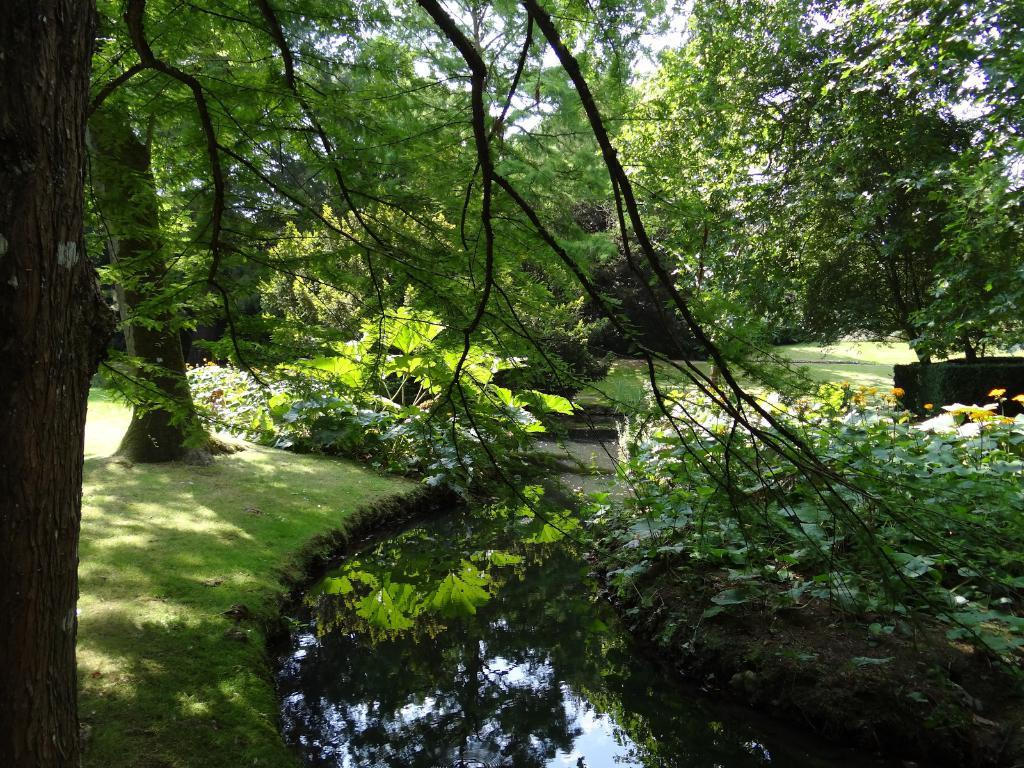What type of vegetation can be seen in the image? There are trees in the image. What is the color of the trees in the image? The trees are green in color. What else is visible in the image besides the trees? The sky is visible in the image. What is the color of the sky in the image? The sky is white in color. How many pizzas are stacked on top of the structure in the image? There is no structure or pizzas present in the image; it only features trees and the sky. 